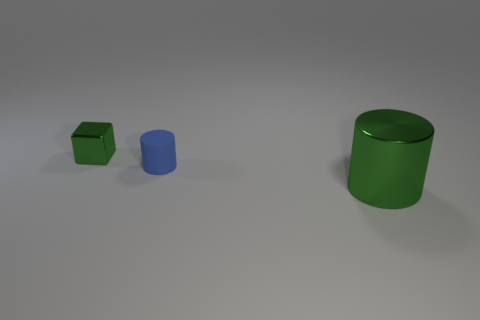Subtract all gray cylinders. Subtract all red blocks. How many cylinders are left? 2 Add 3 large brown rubber balls. How many objects exist? 6 Subtract all cubes. How many objects are left? 2 Subtract 1 green cylinders. How many objects are left? 2 Subtract all tiny cylinders. Subtract all big green metal things. How many objects are left? 1 Add 2 big green things. How many big green things are left? 3 Add 3 green cylinders. How many green cylinders exist? 4 